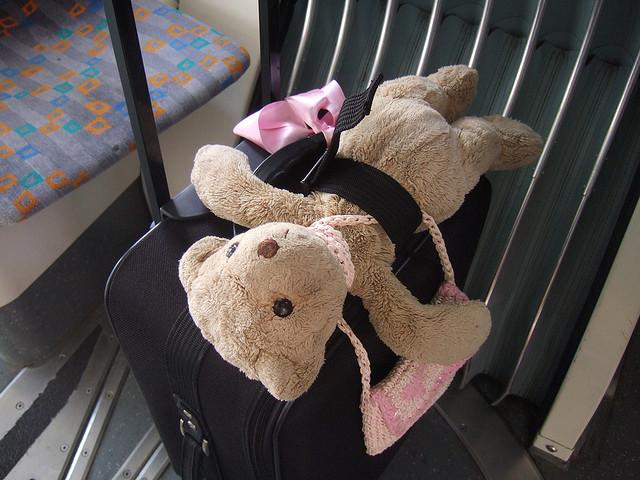Is the brown item a toy?
Write a very short answer. Yes. What is the teddy bear strapped to?
Give a very brief answer. Suitcase. What color is the purse?
Answer briefly. Pink. 